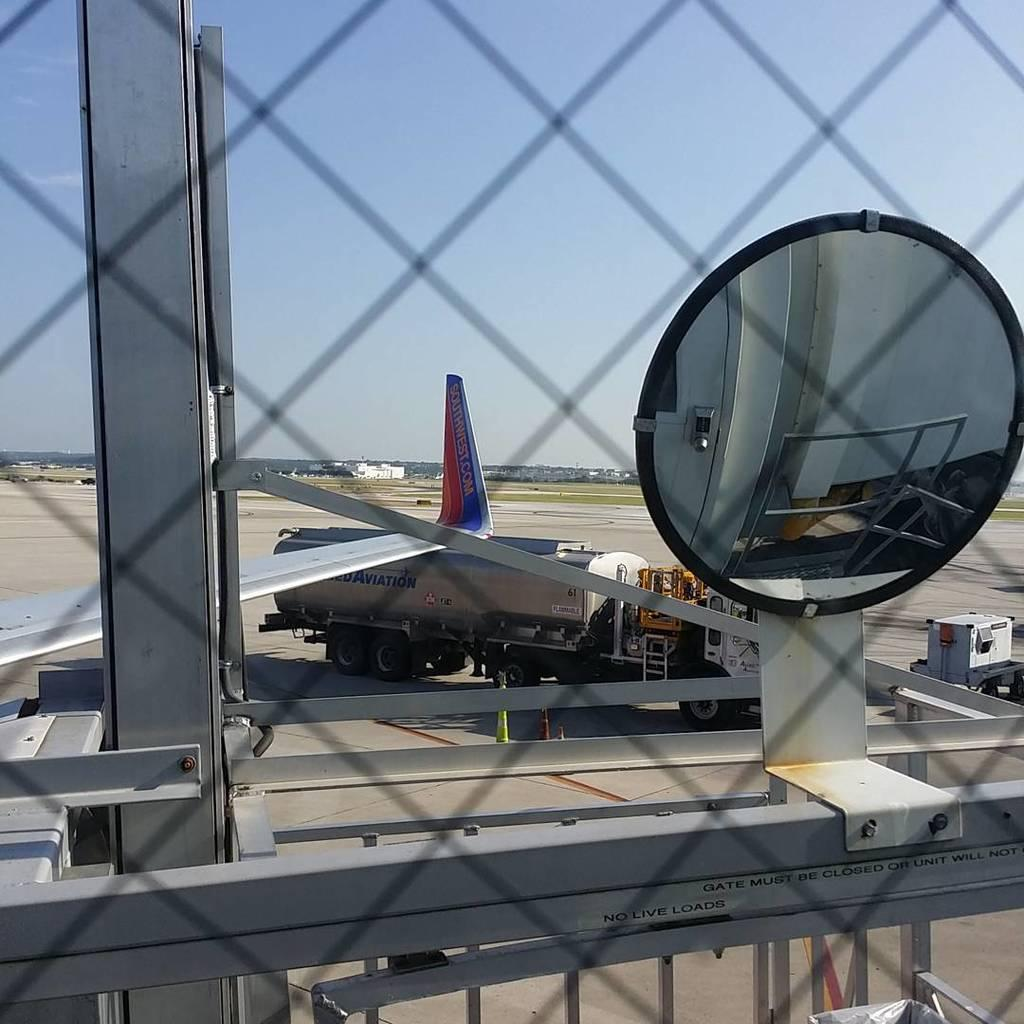<image>
Describe the image concisely. A Southwest airplane at an airport next to a fuel truck 